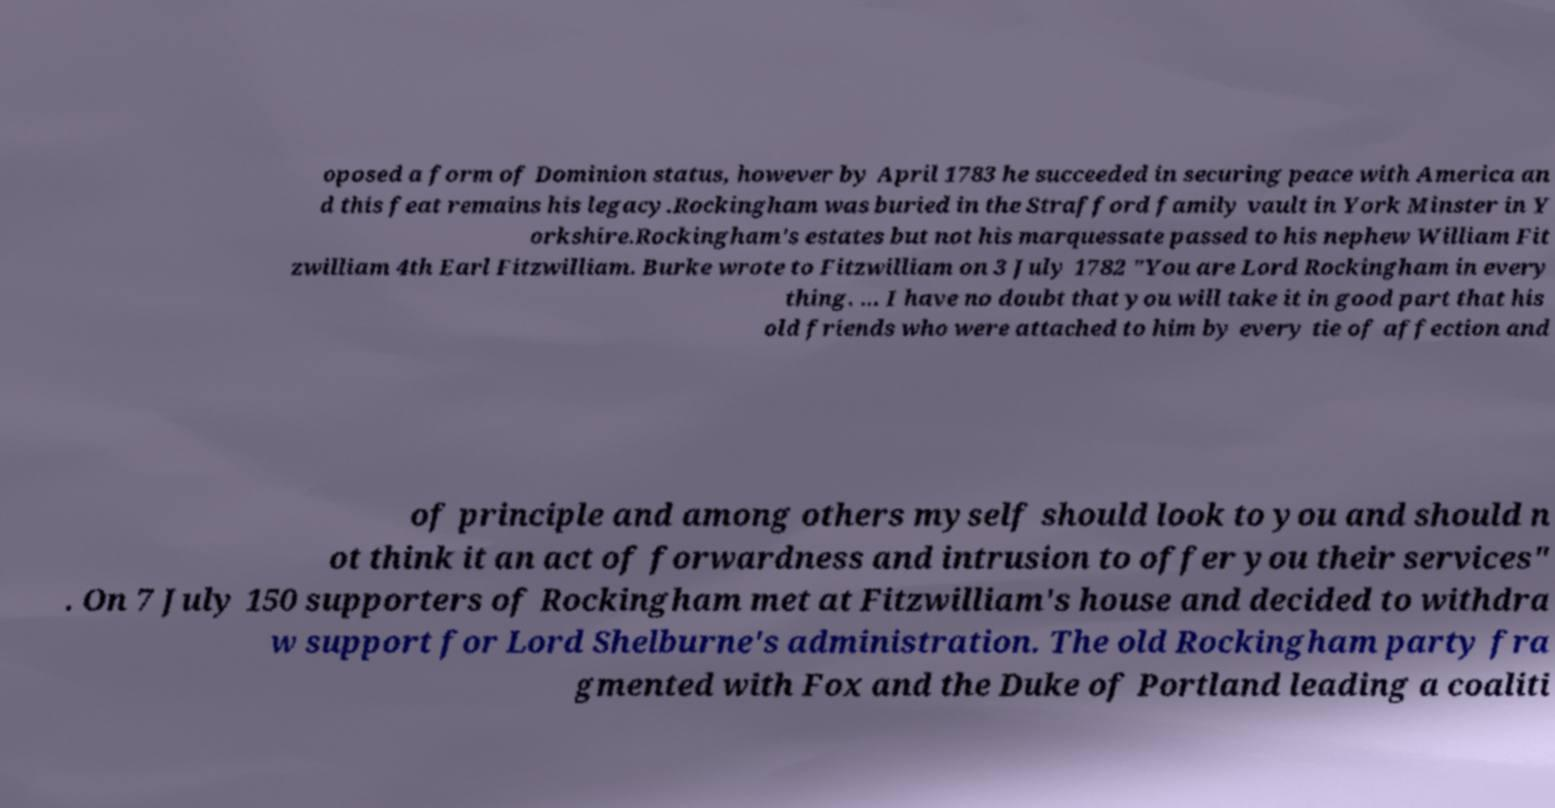Could you extract and type out the text from this image? oposed a form of Dominion status, however by April 1783 he succeeded in securing peace with America an d this feat remains his legacy.Rockingham was buried in the Strafford family vault in York Minster in Y orkshire.Rockingham's estates but not his marquessate passed to his nephew William Fit zwilliam 4th Earl Fitzwilliam. Burke wrote to Fitzwilliam on 3 July 1782 "You are Lord Rockingham in every thing. ... I have no doubt that you will take it in good part that his old friends who were attached to him by every tie of affection and of principle and among others myself should look to you and should n ot think it an act of forwardness and intrusion to offer you their services" . On 7 July 150 supporters of Rockingham met at Fitzwilliam's house and decided to withdra w support for Lord Shelburne's administration. The old Rockingham party fra gmented with Fox and the Duke of Portland leading a coaliti 